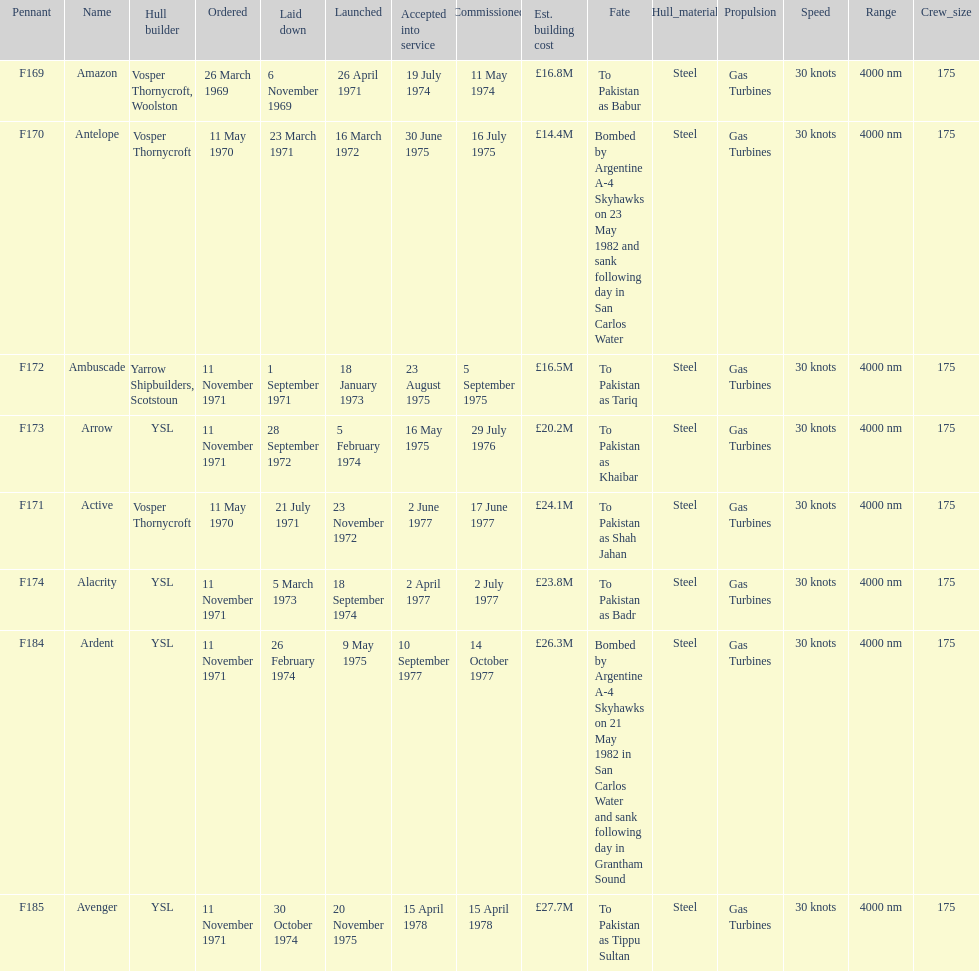What is the name of the ship listed after ardent? Avenger. 